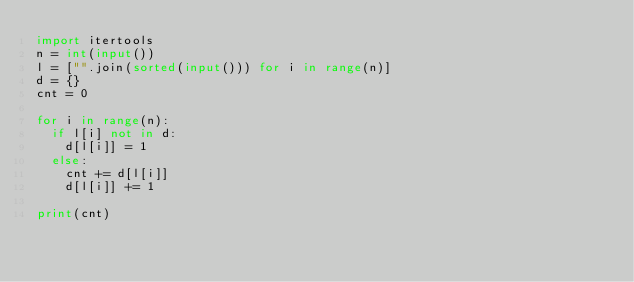Convert code to text. <code><loc_0><loc_0><loc_500><loc_500><_Python_>import itertools
n = int(input())
l = ["".join(sorted(input())) for i in range(n)]
d = {}
cnt = 0

for i in range(n):
  if l[i] not in d:
    d[l[i]] = 1
  else:
    cnt += d[l[i]]
    d[l[i]] += 1

print(cnt)</code> 